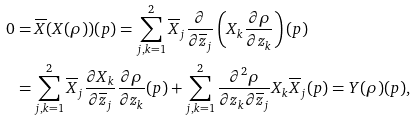<formula> <loc_0><loc_0><loc_500><loc_500>0 & = \overline { X } ( X ( \rho ) ) ( p ) = \sum _ { j , k = 1 } ^ { 2 } \overline { X } _ { j } \frac { \partial } { \partial \overline { z } _ { j } } \left ( X _ { k } \frac { \partial \rho } { \partial z _ { k } } \right ) ( p ) \\ & = \sum _ { j , k = 1 } ^ { 2 } \overline { X } _ { j } \frac { \partial X _ { k } } { \partial \overline { z } _ { j } } \frac { \partial \rho } { \partial z _ { k } } ( p ) + \sum _ { j , k = 1 } ^ { 2 } \frac { \partial ^ { 2 } \rho } { \partial z _ { k } \partial \overline { z } _ { j } } X _ { k } \overline { X } _ { j } ( p ) = Y ( \rho ) ( p ) ,</formula> 